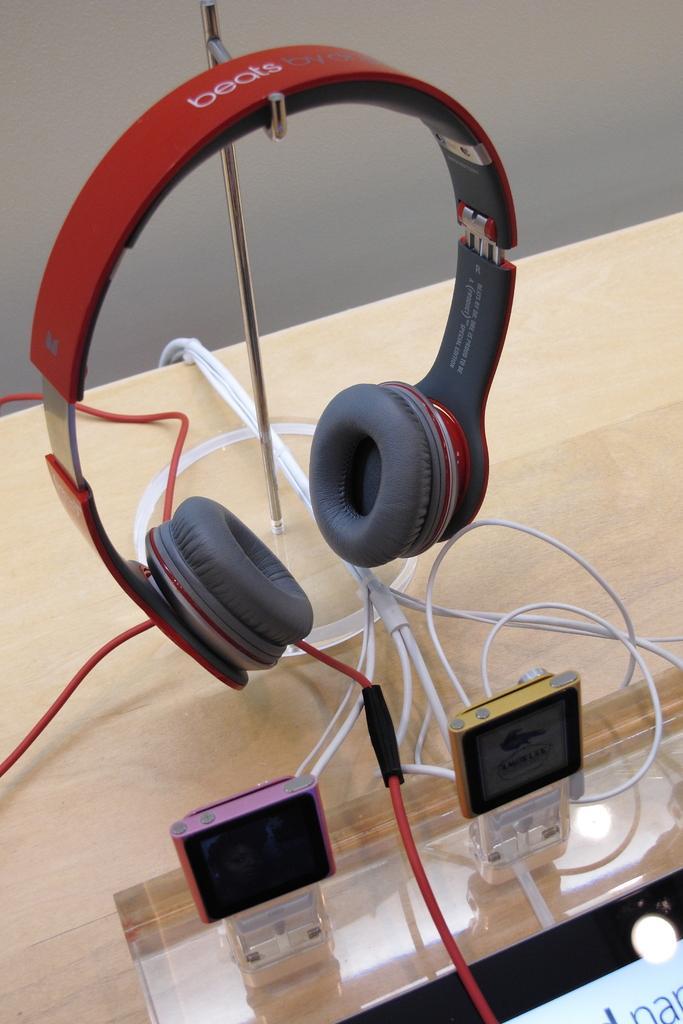Describe this image in one or two sentences. This image is taken indoors. In the background there is a wall. At the bottom of the image there is a table with a few wires and two devices on it. There is a board with a text on it. In the middle of the image there is a headset on the hanger. 